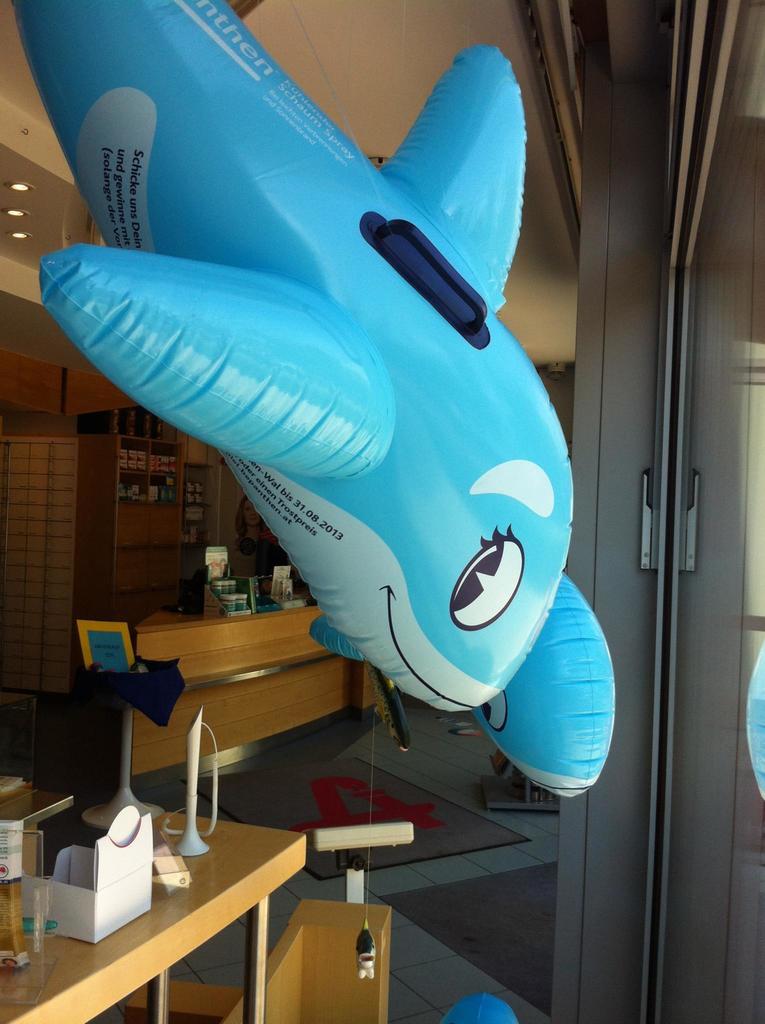What is the date on the belly of the shark?
Provide a short and direct response. Unanswerable. What type of spray is written near the tail of the shark?
Ensure brevity in your answer.  Unanswerable. 